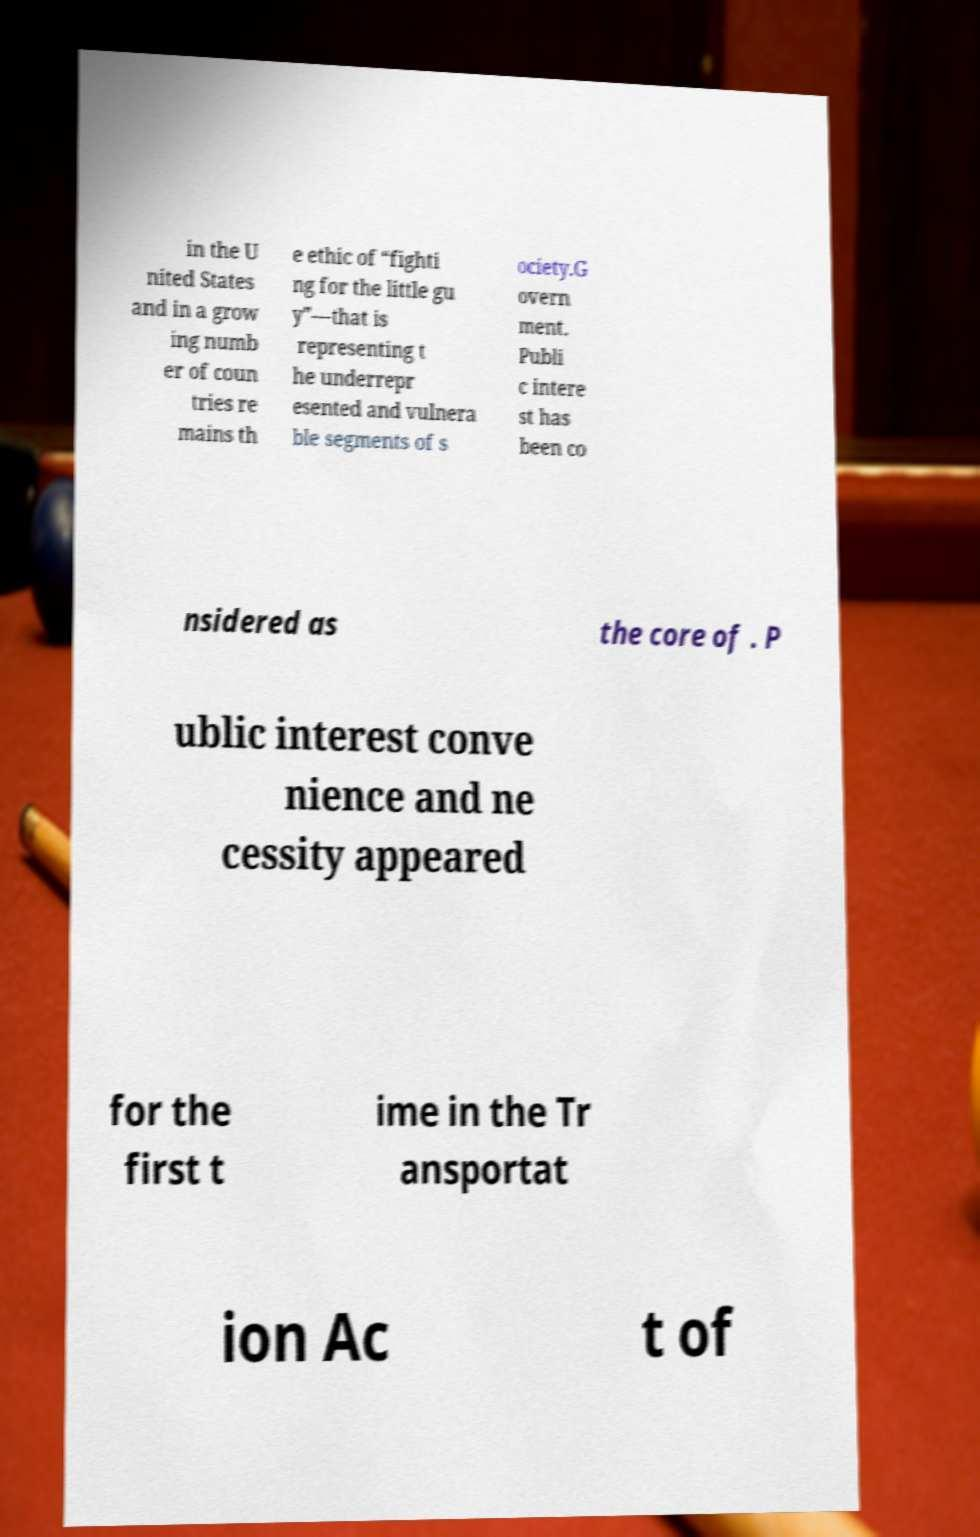I need the written content from this picture converted into text. Can you do that? in the U nited States and in a grow ing numb er of coun tries re mains th e ethic of “fighti ng for the little gu y”—that is representing t he underrepr esented and vulnera ble segments of s ociety.G overn ment. Publi c intere st has been co nsidered as the core of . P ublic interest conve nience and ne cessity appeared for the first t ime in the Tr ansportat ion Ac t of 